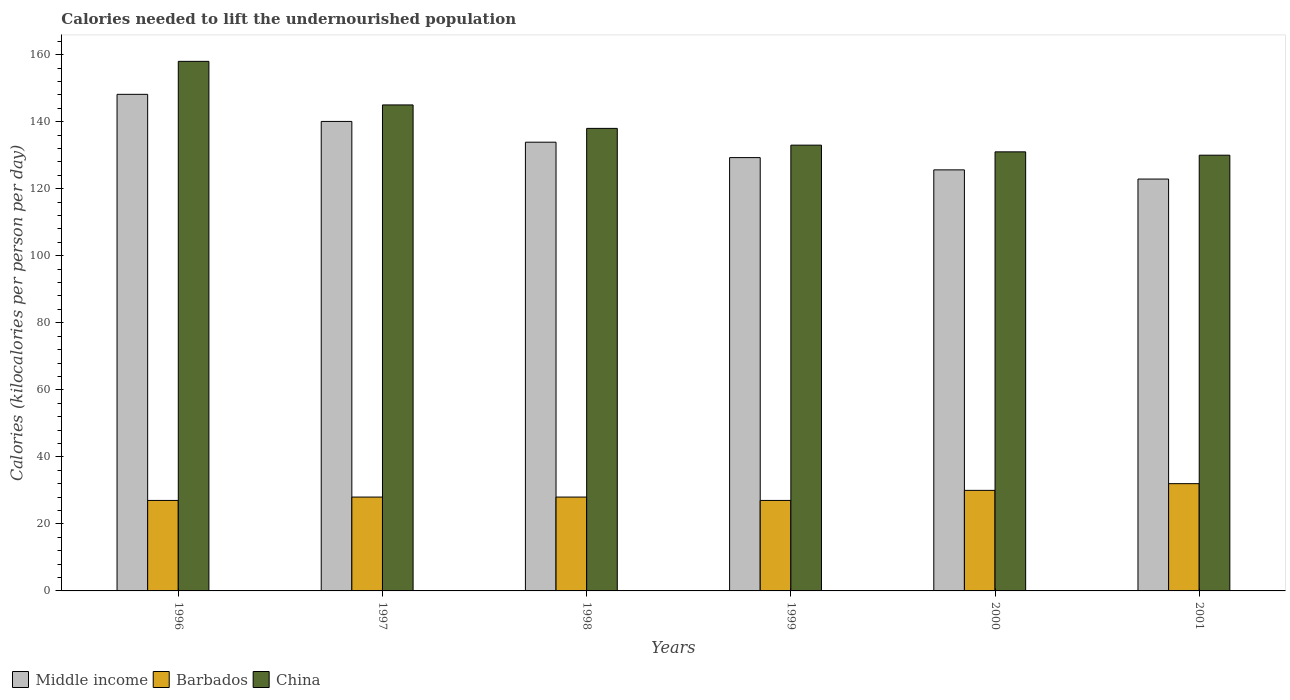How many different coloured bars are there?
Your answer should be compact. 3. How many groups of bars are there?
Keep it short and to the point. 6. Are the number of bars on each tick of the X-axis equal?
Your answer should be compact. Yes. How many bars are there on the 6th tick from the right?
Your response must be concise. 3. In how many cases, is the number of bars for a given year not equal to the number of legend labels?
Keep it short and to the point. 0. What is the total calories needed to lift the undernourished population in Middle income in 1996?
Keep it short and to the point. 148.16. Across all years, what is the maximum total calories needed to lift the undernourished population in China?
Offer a terse response. 158. Across all years, what is the minimum total calories needed to lift the undernourished population in Middle income?
Make the answer very short. 122.88. In which year was the total calories needed to lift the undernourished population in Middle income minimum?
Keep it short and to the point. 2001. What is the total total calories needed to lift the undernourished population in Middle income in the graph?
Provide a succinct answer. 799.91. What is the difference between the total calories needed to lift the undernourished population in China in 1997 and that in 2001?
Provide a succinct answer. 15. What is the difference between the total calories needed to lift the undernourished population in Middle income in 1997 and the total calories needed to lift the undernourished population in China in 2001?
Ensure brevity in your answer.  10.08. What is the average total calories needed to lift the undernourished population in Barbados per year?
Your answer should be compact. 28.67. In the year 2001, what is the difference between the total calories needed to lift the undernourished population in Barbados and total calories needed to lift the undernourished population in Middle income?
Ensure brevity in your answer.  -90.88. What is the difference between the highest and the second highest total calories needed to lift the undernourished population in Middle income?
Offer a terse response. 8.08. What is the difference between the highest and the lowest total calories needed to lift the undernourished population in Middle income?
Give a very brief answer. 25.28. Is the sum of the total calories needed to lift the undernourished population in Middle income in 1998 and 2001 greater than the maximum total calories needed to lift the undernourished population in Barbados across all years?
Ensure brevity in your answer.  Yes. What does the 2nd bar from the left in 1999 represents?
Give a very brief answer. Barbados. Is it the case that in every year, the sum of the total calories needed to lift the undernourished population in Middle income and total calories needed to lift the undernourished population in China is greater than the total calories needed to lift the undernourished population in Barbados?
Ensure brevity in your answer.  Yes. Are all the bars in the graph horizontal?
Provide a succinct answer. No. Are the values on the major ticks of Y-axis written in scientific E-notation?
Provide a succinct answer. No. Where does the legend appear in the graph?
Ensure brevity in your answer.  Bottom left. How many legend labels are there?
Make the answer very short. 3. How are the legend labels stacked?
Provide a succinct answer. Horizontal. What is the title of the graph?
Offer a very short reply. Calories needed to lift the undernourished population. Does "Sint Maarten (Dutch part)" appear as one of the legend labels in the graph?
Your answer should be compact. No. What is the label or title of the Y-axis?
Your answer should be very brief. Calories (kilocalories per person per day). What is the Calories (kilocalories per person per day) of Middle income in 1996?
Make the answer very short. 148.16. What is the Calories (kilocalories per person per day) of China in 1996?
Your answer should be very brief. 158. What is the Calories (kilocalories per person per day) in Middle income in 1997?
Provide a succinct answer. 140.08. What is the Calories (kilocalories per person per day) in China in 1997?
Ensure brevity in your answer.  145. What is the Calories (kilocalories per person per day) of Middle income in 1998?
Offer a very short reply. 133.88. What is the Calories (kilocalories per person per day) in Barbados in 1998?
Provide a short and direct response. 28. What is the Calories (kilocalories per person per day) in China in 1998?
Give a very brief answer. 138. What is the Calories (kilocalories per person per day) in Middle income in 1999?
Keep it short and to the point. 129.29. What is the Calories (kilocalories per person per day) of Barbados in 1999?
Your response must be concise. 27. What is the Calories (kilocalories per person per day) of China in 1999?
Offer a very short reply. 133. What is the Calories (kilocalories per person per day) of Middle income in 2000?
Ensure brevity in your answer.  125.62. What is the Calories (kilocalories per person per day) in China in 2000?
Your response must be concise. 131. What is the Calories (kilocalories per person per day) in Middle income in 2001?
Provide a short and direct response. 122.88. What is the Calories (kilocalories per person per day) of China in 2001?
Your answer should be very brief. 130. Across all years, what is the maximum Calories (kilocalories per person per day) in Middle income?
Your answer should be very brief. 148.16. Across all years, what is the maximum Calories (kilocalories per person per day) in Barbados?
Your answer should be very brief. 32. Across all years, what is the maximum Calories (kilocalories per person per day) in China?
Your answer should be compact. 158. Across all years, what is the minimum Calories (kilocalories per person per day) of Middle income?
Provide a short and direct response. 122.88. Across all years, what is the minimum Calories (kilocalories per person per day) in China?
Offer a terse response. 130. What is the total Calories (kilocalories per person per day) of Middle income in the graph?
Provide a succinct answer. 799.91. What is the total Calories (kilocalories per person per day) in Barbados in the graph?
Your answer should be compact. 172. What is the total Calories (kilocalories per person per day) in China in the graph?
Ensure brevity in your answer.  835. What is the difference between the Calories (kilocalories per person per day) in Middle income in 1996 and that in 1997?
Provide a succinct answer. 8.08. What is the difference between the Calories (kilocalories per person per day) of Barbados in 1996 and that in 1997?
Offer a terse response. -1. What is the difference between the Calories (kilocalories per person per day) of Middle income in 1996 and that in 1998?
Give a very brief answer. 14.28. What is the difference between the Calories (kilocalories per person per day) of Barbados in 1996 and that in 1998?
Make the answer very short. -1. What is the difference between the Calories (kilocalories per person per day) of China in 1996 and that in 1998?
Give a very brief answer. 20. What is the difference between the Calories (kilocalories per person per day) of Middle income in 1996 and that in 1999?
Your response must be concise. 18.87. What is the difference between the Calories (kilocalories per person per day) of Barbados in 1996 and that in 1999?
Provide a short and direct response. 0. What is the difference between the Calories (kilocalories per person per day) of Middle income in 1996 and that in 2000?
Ensure brevity in your answer.  22.53. What is the difference between the Calories (kilocalories per person per day) of Barbados in 1996 and that in 2000?
Offer a very short reply. -3. What is the difference between the Calories (kilocalories per person per day) in China in 1996 and that in 2000?
Provide a short and direct response. 27. What is the difference between the Calories (kilocalories per person per day) of Middle income in 1996 and that in 2001?
Make the answer very short. 25.28. What is the difference between the Calories (kilocalories per person per day) of Barbados in 1996 and that in 2001?
Your answer should be very brief. -5. What is the difference between the Calories (kilocalories per person per day) in Middle income in 1997 and that in 1998?
Offer a very short reply. 6.2. What is the difference between the Calories (kilocalories per person per day) in Barbados in 1997 and that in 1998?
Your response must be concise. 0. What is the difference between the Calories (kilocalories per person per day) in Middle income in 1997 and that in 1999?
Your answer should be very brief. 10.79. What is the difference between the Calories (kilocalories per person per day) in Barbados in 1997 and that in 1999?
Provide a short and direct response. 1. What is the difference between the Calories (kilocalories per person per day) of Middle income in 1997 and that in 2000?
Ensure brevity in your answer.  14.45. What is the difference between the Calories (kilocalories per person per day) of China in 1997 and that in 2000?
Offer a terse response. 14. What is the difference between the Calories (kilocalories per person per day) of Middle income in 1997 and that in 2001?
Ensure brevity in your answer.  17.2. What is the difference between the Calories (kilocalories per person per day) of Middle income in 1998 and that in 1999?
Offer a terse response. 4.6. What is the difference between the Calories (kilocalories per person per day) in Barbados in 1998 and that in 1999?
Offer a very short reply. 1. What is the difference between the Calories (kilocalories per person per day) of Middle income in 1998 and that in 2000?
Provide a short and direct response. 8.26. What is the difference between the Calories (kilocalories per person per day) of China in 1998 and that in 2000?
Your answer should be compact. 7. What is the difference between the Calories (kilocalories per person per day) of Middle income in 1998 and that in 2001?
Provide a short and direct response. 11. What is the difference between the Calories (kilocalories per person per day) of China in 1998 and that in 2001?
Ensure brevity in your answer.  8. What is the difference between the Calories (kilocalories per person per day) in Middle income in 1999 and that in 2000?
Give a very brief answer. 3.66. What is the difference between the Calories (kilocalories per person per day) in Barbados in 1999 and that in 2000?
Your answer should be compact. -3. What is the difference between the Calories (kilocalories per person per day) of China in 1999 and that in 2000?
Your response must be concise. 2. What is the difference between the Calories (kilocalories per person per day) in Middle income in 1999 and that in 2001?
Make the answer very short. 6.4. What is the difference between the Calories (kilocalories per person per day) of Middle income in 2000 and that in 2001?
Ensure brevity in your answer.  2.74. What is the difference between the Calories (kilocalories per person per day) in Barbados in 2000 and that in 2001?
Give a very brief answer. -2. What is the difference between the Calories (kilocalories per person per day) of Middle income in 1996 and the Calories (kilocalories per person per day) of Barbados in 1997?
Keep it short and to the point. 120.16. What is the difference between the Calories (kilocalories per person per day) of Middle income in 1996 and the Calories (kilocalories per person per day) of China in 1997?
Your answer should be compact. 3.16. What is the difference between the Calories (kilocalories per person per day) of Barbados in 1996 and the Calories (kilocalories per person per day) of China in 1997?
Your answer should be compact. -118. What is the difference between the Calories (kilocalories per person per day) of Middle income in 1996 and the Calories (kilocalories per person per day) of Barbados in 1998?
Offer a terse response. 120.16. What is the difference between the Calories (kilocalories per person per day) in Middle income in 1996 and the Calories (kilocalories per person per day) in China in 1998?
Offer a terse response. 10.16. What is the difference between the Calories (kilocalories per person per day) in Barbados in 1996 and the Calories (kilocalories per person per day) in China in 1998?
Keep it short and to the point. -111. What is the difference between the Calories (kilocalories per person per day) of Middle income in 1996 and the Calories (kilocalories per person per day) of Barbados in 1999?
Keep it short and to the point. 121.16. What is the difference between the Calories (kilocalories per person per day) in Middle income in 1996 and the Calories (kilocalories per person per day) in China in 1999?
Provide a short and direct response. 15.16. What is the difference between the Calories (kilocalories per person per day) in Barbados in 1996 and the Calories (kilocalories per person per day) in China in 1999?
Your answer should be very brief. -106. What is the difference between the Calories (kilocalories per person per day) of Middle income in 1996 and the Calories (kilocalories per person per day) of Barbados in 2000?
Your answer should be compact. 118.16. What is the difference between the Calories (kilocalories per person per day) of Middle income in 1996 and the Calories (kilocalories per person per day) of China in 2000?
Your response must be concise. 17.16. What is the difference between the Calories (kilocalories per person per day) in Barbados in 1996 and the Calories (kilocalories per person per day) in China in 2000?
Keep it short and to the point. -104. What is the difference between the Calories (kilocalories per person per day) of Middle income in 1996 and the Calories (kilocalories per person per day) of Barbados in 2001?
Provide a succinct answer. 116.16. What is the difference between the Calories (kilocalories per person per day) of Middle income in 1996 and the Calories (kilocalories per person per day) of China in 2001?
Your response must be concise. 18.16. What is the difference between the Calories (kilocalories per person per day) of Barbados in 1996 and the Calories (kilocalories per person per day) of China in 2001?
Your response must be concise. -103. What is the difference between the Calories (kilocalories per person per day) in Middle income in 1997 and the Calories (kilocalories per person per day) in Barbados in 1998?
Give a very brief answer. 112.08. What is the difference between the Calories (kilocalories per person per day) of Middle income in 1997 and the Calories (kilocalories per person per day) of China in 1998?
Make the answer very short. 2.08. What is the difference between the Calories (kilocalories per person per day) in Barbados in 1997 and the Calories (kilocalories per person per day) in China in 1998?
Offer a terse response. -110. What is the difference between the Calories (kilocalories per person per day) in Middle income in 1997 and the Calories (kilocalories per person per day) in Barbados in 1999?
Your response must be concise. 113.08. What is the difference between the Calories (kilocalories per person per day) of Middle income in 1997 and the Calories (kilocalories per person per day) of China in 1999?
Provide a succinct answer. 7.08. What is the difference between the Calories (kilocalories per person per day) of Barbados in 1997 and the Calories (kilocalories per person per day) of China in 1999?
Your response must be concise. -105. What is the difference between the Calories (kilocalories per person per day) in Middle income in 1997 and the Calories (kilocalories per person per day) in Barbados in 2000?
Keep it short and to the point. 110.08. What is the difference between the Calories (kilocalories per person per day) in Middle income in 1997 and the Calories (kilocalories per person per day) in China in 2000?
Offer a very short reply. 9.08. What is the difference between the Calories (kilocalories per person per day) in Barbados in 1997 and the Calories (kilocalories per person per day) in China in 2000?
Your answer should be very brief. -103. What is the difference between the Calories (kilocalories per person per day) in Middle income in 1997 and the Calories (kilocalories per person per day) in Barbados in 2001?
Keep it short and to the point. 108.08. What is the difference between the Calories (kilocalories per person per day) in Middle income in 1997 and the Calories (kilocalories per person per day) in China in 2001?
Offer a terse response. 10.08. What is the difference between the Calories (kilocalories per person per day) in Barbados in 1997 and the Calories (kilocalories per person per day) in China in 2001?
Give a very brief answer. -102. What is the difference between the Calories (kilocalories per person per day) of Middle income in 1998 and the Calories (kilocalories per person per day) of Barbados in 1999?
Keep it short and to the point. 106.88. What is the difference between the Calories (kilocalories per person per day) of Middle income in 1998 and the Calories (kilocalories per person per day) of China in 1999?
Offer a very short reply. 0.88. What is the difference between the Calories (kilocalories per person per day) in Barbados in 1998 and the Calories (kilocalories per person per day) in China in 1999?
Offer a very short reply. -105. What is the difference between the Calories (kilocalories per person per day) in Middle income in 1998 and the Calories (kilocalories per person per day) in Barbados in 2000?
Ensure brevity in your answer.  103.88. What is the difference between the Calories (kilocalories per person per day) in Middle income in 1998 and the Calories (kilocalories per person per day) in China in 2000?
Provide a succinct answer. 2.88. What is the difference between the Calories (kilocalories per person per day) in Barbados in 1998 and the Calories (kilocalories per person per day) in China in 2000?
Make the answer very short. -103. What is the difference between the Calories (kilocalories per person per day) of Middle income in 1998 and the Calories (kilocalories per person per day) of Barbados in 2001?
Provide a succinct answer. 101.88. What is the difference between the Calories (kilocalories per person per day) in Middle income in 1998 and the Calories (kilocalories per person per day) in China in 2001?
Your answer should be compact. 3.88. What is the difference between the Calories (kilocalories per person per day) in Barbados in 1998 and the Calories (kilocalories per person per day) in China in 2001?
Your response must be concise. -102. What is the difference between the Calories (kilocalories per person per day) in Middle income in 1999 and the Calories (kilocalories per person per day) in Barbados in 2000?
Ensure brevity in your answer.  99.29. What is the difference between the Calories (kilocalories per person per day) in Middle income in 1999 and the Calories (kilocalories per person per day) in China in 2000?
Your answer should be very brief. -1.71. What is the difference between the Calories (kilocalories per person per day) in Barbados in 1999 and the Calories (kilocalories per person per day) in China in 2000?
Offer a terse response. -104. What is the difference between the Calories (kilocalories per person per day) of Middle income in 1999 and the Calories (kilocalories per person per day) of Barbados in 2001?
Provide a short and direct response. 97.29. What is the difference between the Calories (kilocalories per person per day) of Middle income in 1999 and the Calories (kilocalories per person per day) of China in 2001?
Provide a short and direct response. -0.71. What is the difference between the Calories (kilocalories per person per day) of Barbados in 1999 and the Calories (kilocalories per person per day) of China in 2001?
Provide a succinct answer. -103. What is the difference between the Calories (kilocalories per person per day) in Middle income in 2000 and the Calories (kilocalories per person per day) in Barbados in 2001?
Ensure brevity in your answer.  93.62. What is the difference between the Calories (kilocalories per person per day) in Middle income in 2000 and the Calories (kilocalories per person per day) in China in 2001?
Ensure brevity in your answer.  -4.38. What is the difference between the Calories (kilocalories per person per day) of Barbados in 2000 and the Calories (kilocalories per person per day) of China in 2001?
Keep it short and to the point. -100. What is the average Calories (kilocalories per person per day) in Middle income per year?
Ensure brevity in your answer.  133.32. What is the average Calories (kilocalories per person per day) of Barbados per year?
Offer a very short reply. 28.67. What is the average Calories (kilocalories per person per day) in China per year?
Offer a very short reply. 139.17. In the year 1996, what is the difference between the Calories (kilocalories per person per day) of Middle income and Calories (kilocalories per person per day) of Barbados?
Give a very brief answer. 121.16. In the year 1996, what is the difference between the Calories (kilocalories per person per day) in Middle income and Calories (kilocalories per person per day) in China?
Offer a terse response. -9.84. In the year 1996, what is the difference between the Calories (kilocalories per person per day) in Barbados and Calories (kilocalories per person per day) in China?
Offer a terse response. -131. In the year 1997, what is the difference between the Calories (kilocalories per person per day) in Middle income and Calories (kilocalories per person per day) in Barbados?
Make the answer very short. 112.08. In the year 1997, what is the difference between the Calories (kilocalories per person per day) of Middle income and Calories (kilocalories per person per day) of China?
Make the answer very short. -4.92. In the year 1997, what is the difference between the Calories (kilocalories per person per day) of Barbados and Calories (kilocalories per person per day) of China?
Offer a very short reply. -117. In the year 1998, what is the difference between the Calories (kilocalories per person per day) in Middle income and Calories (kilocalories per person per day) in Barbados?
Give a very brief answer. 105.88. In the year 1998, what is the difference between the Calories (kilocalories per person per day) of Middle income and Calories (kilocalories per person per day) of China?
Offer a very short reply. -4.12. In the year 1998, what is the difference between the Calories (kilocalories per person per day) in Barbados and Calories (kilocalories per person per day) in China?
Make the answer very short. -110. In the year 1999, what is the difference between the Calories (kilocalories per person per day) of Middle income and Calories (kilocalories per person per day) of Barbados?
Provide a short and direct response. 102.29. In the year 1999, what is the difference between the Calories (kilocalories per person per day) of Middle income and Calories (kilocalories per person per day) of China?
Your answer should be very brief. -3.71. In the year 1999, what is the difference between the Calories (kilocalories per person per day) of Barbados and Calories (kilocalories per person per day) of China?
Your answer should be very brief. -106. In the year 2000, what is the difference between the Calories (kilocalories per person per day) in Middle income and Calories (kilocalories per person per day) in Barbados?
Your answer should be compact. 95.62. In the year 2000, what is the difference between the Calories (kilocalories per person per day) of Middle income and Calories (kilocalories per person per day) of China?
Offer a very short reply. -5.38. In the year 2000, what is the difference between the Calories (kilocalories per person per day) of Barbados and Calories (kilocalories per person per day) of China?
Keep it short and to the point. -101. In the year 2001, what is the difference between the Calories (kilocalories per person per day) in Middle income and Calories (kilocalories per person per day) in Barbados?
Your answer should be very brief. 90.88. In the year 2001, what is the difference between the Calories (kilocalories per person per day) of Middle income and Calories (kilocalories per person per day) of China?
Give a very brief answer. -7.12. In the year 2001, what is the difference between the Calories (kilocalories per person per day) of Barbados and Calories (kilocalories per person per day) of China?
Give a very brief answer. -98. What is the ratio of the Calories (kilocalories per person per day) of Middle income in 1996 to that in 1997?
Ensure brevity in your answer.  1.06. What is the ratio of the Calories (kilocalories per person per day) in China in 1996 to that in 1997?
Keep it short and to the point. 1.09. What is the ratio of the Calories (kilocalories per person per day) of Middle income in 1996 to that in 1998?
Ensure brevity in your answer.  1.11. What is the ratio of the Calories (kilocalories per person per day) of China in 1996 to that in 1998?
Your response must be concise. 1.14. What is the ratio of the Calories (kilocalories per person per day) in Middle income in 1996 to that in 1999?
Provide a short and direct response. 1.15. What is the ratio of the Calories (kilocalories per person per day) in China in 1996 to that in 1999?
Make the answer very short. 1.19. What is the ratio of the Calories (kilocalories per person per day) in Middle income in 1996 to that in 2000?
Your answer should be compact. 1.18. What is the ratio of the Calories (kilocalories per person per day) of China in 1996 to that in 2000?
Your answer should be very brief. 1.21. What is the ratio of the Calories (kilocalories per person per day) of Middle income in 1996 to that in 2001?
Your response must be concise. 1.21. What is the ratio of the Calories (kilocalories per person per day) of Barbados in 1996 to that in 2001?
Your answer should be very brief. 0.84. What is the ratio of the Calories (kilocalories per person per day) in China in 1996 to that in 2001?
Provide a succinct answer. 1.22. What is the ratio of the Calories (kilocalories per person per day) in Middle income in 1997 to that in 1998?
Your answer should be very brief. 1.05. What is the ratio of the Calories (kilocalories per person per day) in China in 1997 to that in 1998?
Make the answer very short. 1.05. What is the ratio of the Calories (kilocalories per person per day) of Middle income in 1997 to that in 1999?
Give a very brief answer. 1.08. What is the ratio of the Calories (kilocalories per person per day) of Barbados in 1997 to that in 1999?
Offer a very short reply. 1.04. What is the ratio of the Calories (kilocalories per person per day) in China in 1997 to that in 1999?
Your answer should be compact. 1.09. What is the ratio of the Calories (kilocalories per person per day) in Middle income in 1997 to that in 2000?
Ensure brevity in your answer.  1.12. What is the ratio of the Calories (kilocalories per person per day) of China in 1997 to that in 2000?
Keep it short and to the point. 1.11. What is the ratio of the Calories (kilocalories per person per day) in Middle income in 1997 to that in 2001?
Your answer should be compact. 1.14. What is the ratio of the Calories (kilocalories per person per day) of China in 1997 to that in 2001?
Give a very brief answer. 1.12. What is the ratio of the Calories (kilocalories per person per day) of Middle income in 1998 to that in 1999?
Provide a succinct answer. 1.04. What is the ratio of the Calories (kilocalories per person per day) of China in 1998 to that in 1999?
Keep it short and to the point. 1.04. What is the ratio of the Calories (kilocalories per person per day) in Middle income in 1998 to that in 2000?
Your answer should be compact. 1.07. What is the ratio of the Calories (kilocalories per person per day) in China in 1998 to that in 2000?
Your answer should be compact. 1.05. What is the ratio of the Calories (kilocalories per person per day) in Middle income in 1998 to that in 2001?
Your answer should be compact. 1.09. What is the ratio of the Calories (kilocalories per person per day) in China in 1998 to that in 2001?
Offer a terse response. 1.06. What is the ratio of the Calories (kilocalories per person per day) of Middle income in 1999 to that in 2000?
Offer a very short reply. 1.03. What is the ratio of the Calories (kilocalories per person per day) of Barbados in 1999 to that in 2000?
Your answer should be very brief. 0.9. What is the ratio of the Calories (kilocalories per person per day) of China in 1999 to that in 2000?
Your response must be concise. 1.02. What is the ratio of the Calories (kilocalories per person per day) in Middle income in 1999 to that in 2001?
Provide a succinct answer. 1.05. What is the ratio of the Calories (kilocalories per person per day) of Barbados in 1999 to that in 2001?
Offer a very short reply. 0.84. What is the ratio of the Calories (kilocalories per person per day) of China in 1999 to that in 2001?
Provide a succinct answer. 1.02. What is the ratio of the Calories (kilocalories per person per day) of Middle income in 2000 to that in 2001?
Offer a terse response. 1.02. What is the ratio of the Calories (kilocalories per person per day) of Barbados in 2000 to that in 2001?
Your answer should be very brief. 0.94. What is the ratio of the Calories (kilocalories per person per day) of China in 2000 to that in 2001?
Provide a short and direct response. 1.01. What is the difference between the highest and the second highest Calories (kilocalories per person per day) of Middle income?
Provide a succinct answer. 8.08. What is the difference between the highest and the second highest Calories (kilocalories per person per day) in Barbados?
Your answer should be compact. 2. What is the difference between the highest and the lowest Calories (kilocalories per person per day) of Middle income?
Provide a succinct answer. 25.28. 